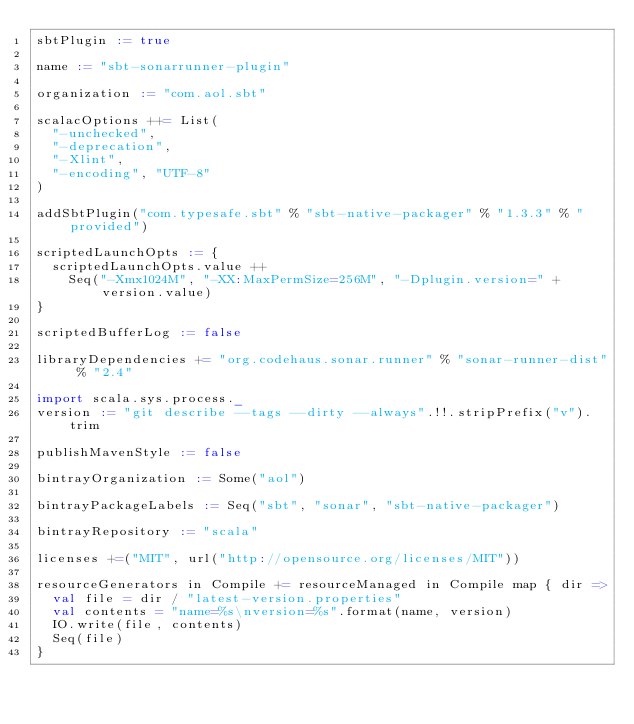Convert code to text. <code><loc_0><loc_0><loc_500><loc_500><_Scala_>sbtPlugin := true

name := "sbt-sonarrunner-plugin"

organization := "com.aol.sbt"

scalacOptions ++= List(
  "-unchecked",
  "-deprecation",
  "-Xlint",
  "-encoding", "UTF-8"
)

addSbtPlugin("com.typesafe.sbt" % "sbt-native-packager" % "1.3.3" % "provided")

scriptedLaunchOpts := {
  scriptedLaunchOpts.value ++
    Seq("-Xmx1024M", "-XX:MaxPermSize=256M", "-Dplugin.version=" + version.value)
}

scriptedBufferLog := false

libraryDependencies += "org.codehaus.sonar.runner" % "sonar-runner-dist" % "2.4"

import scala.sys.process._
version := "git describe --tags --dirty --always".!!.stripPrefix("v").trim

publishMavenStyle := false

bintrayOrganization := Some("aol")

bintrayPackageLabels := Seq("sbt", "sonar", "sbt-native-packager")

bintrayRepository := "scala"

licenses +=("MIT", url("http://opensource.org/licenses/MIT"))

resourceGenerators in Compile += resourceManaged in Compile map { dir =>
  val file = dir / "latest-version.properties"
  val contents = "name=%s\nversion=%s".format(name, version)
  IO.write(file, contents)
  Seq(file)
}</code> 